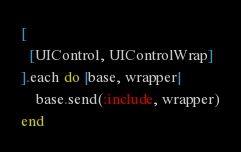<code> <loc_0><loc_0><loc_500><loc_500><_Ruby_>[
  [UIControl, UIControlWrap]
].each do |base, wrapper|
    base.send(:include, wrapper)
end
</code> 